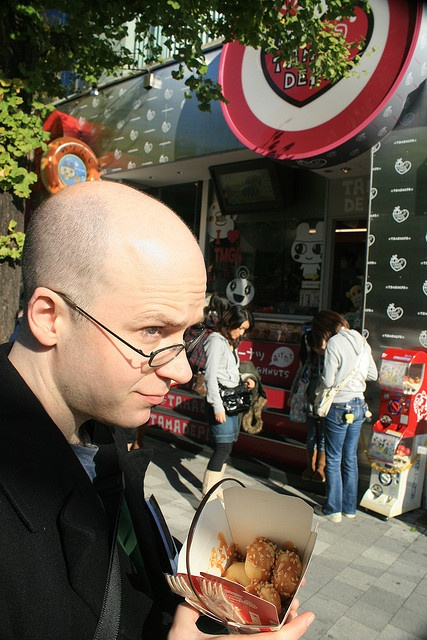Describe the objects in this image and their specific colors. I can see people in black, tan, and beige tones, people in black, ivory, blue, and gray tones, people in black, ivory, gray, and tan tones, people in black, gray, and maroon tones, and donut in black, maroon, brown, and gray tones in this image. 